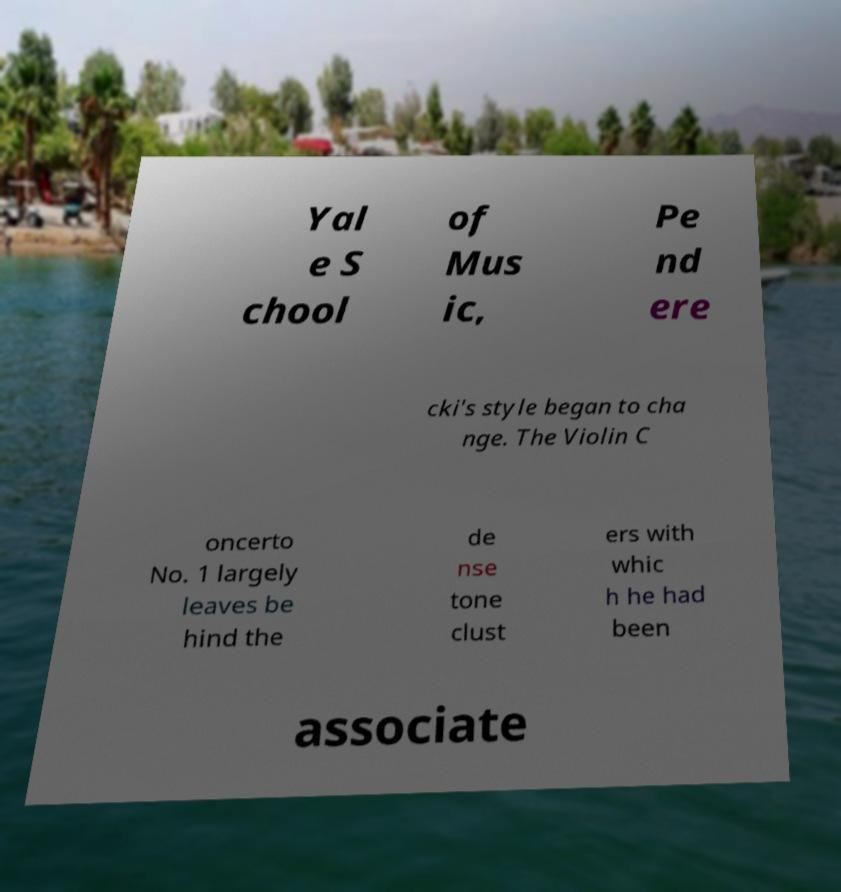Could you extract and type out the text from this image? Yal e S chool of Mus ic, Pe nd ere cki's style began to cha nge. The Violin C oncerto No. 1 largely leaves be hind the de nse tone clust ers with whic h he had been associate 